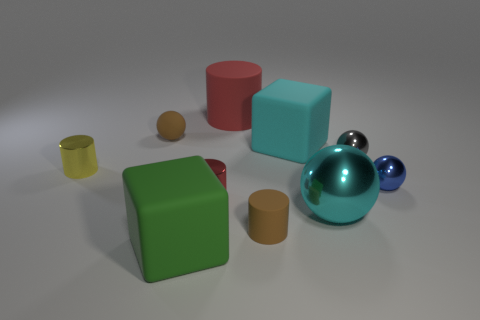Subtract all brown cylinders. How many cylinders are left? 3 Subtract 3 balls. How many balls are left? 1 Add 7 blue spheres. How many blue spheres are left? 8 Add 6 big rubber cylinders. How many big rubber cylinders exist? 7 Subtract all blue spheres. How many spheres are left? 3 Subtract 2 red cylinders. How many objects are left? 8 Subtract all blocks. How many objects are left? 8 Subtract all blue spheres. Subtract all brown cubes. How many spheres are left? 3 Subtract all yellow cylinders. How many cyan balls are left? 1 Subtract all gray cubes. Subtract all tiny yellow things. How many objects are left? 9 